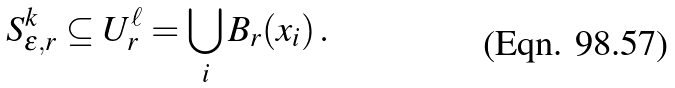<formula> <loc_0><loc_0><loc_500><loc_500>S ^ { k } _ { \epsilon , r } \subseteq U ^ { \ell } _ { r } = \bigcup _ { i } B _ { r } ( x _ { i } ) \, .</formula> 